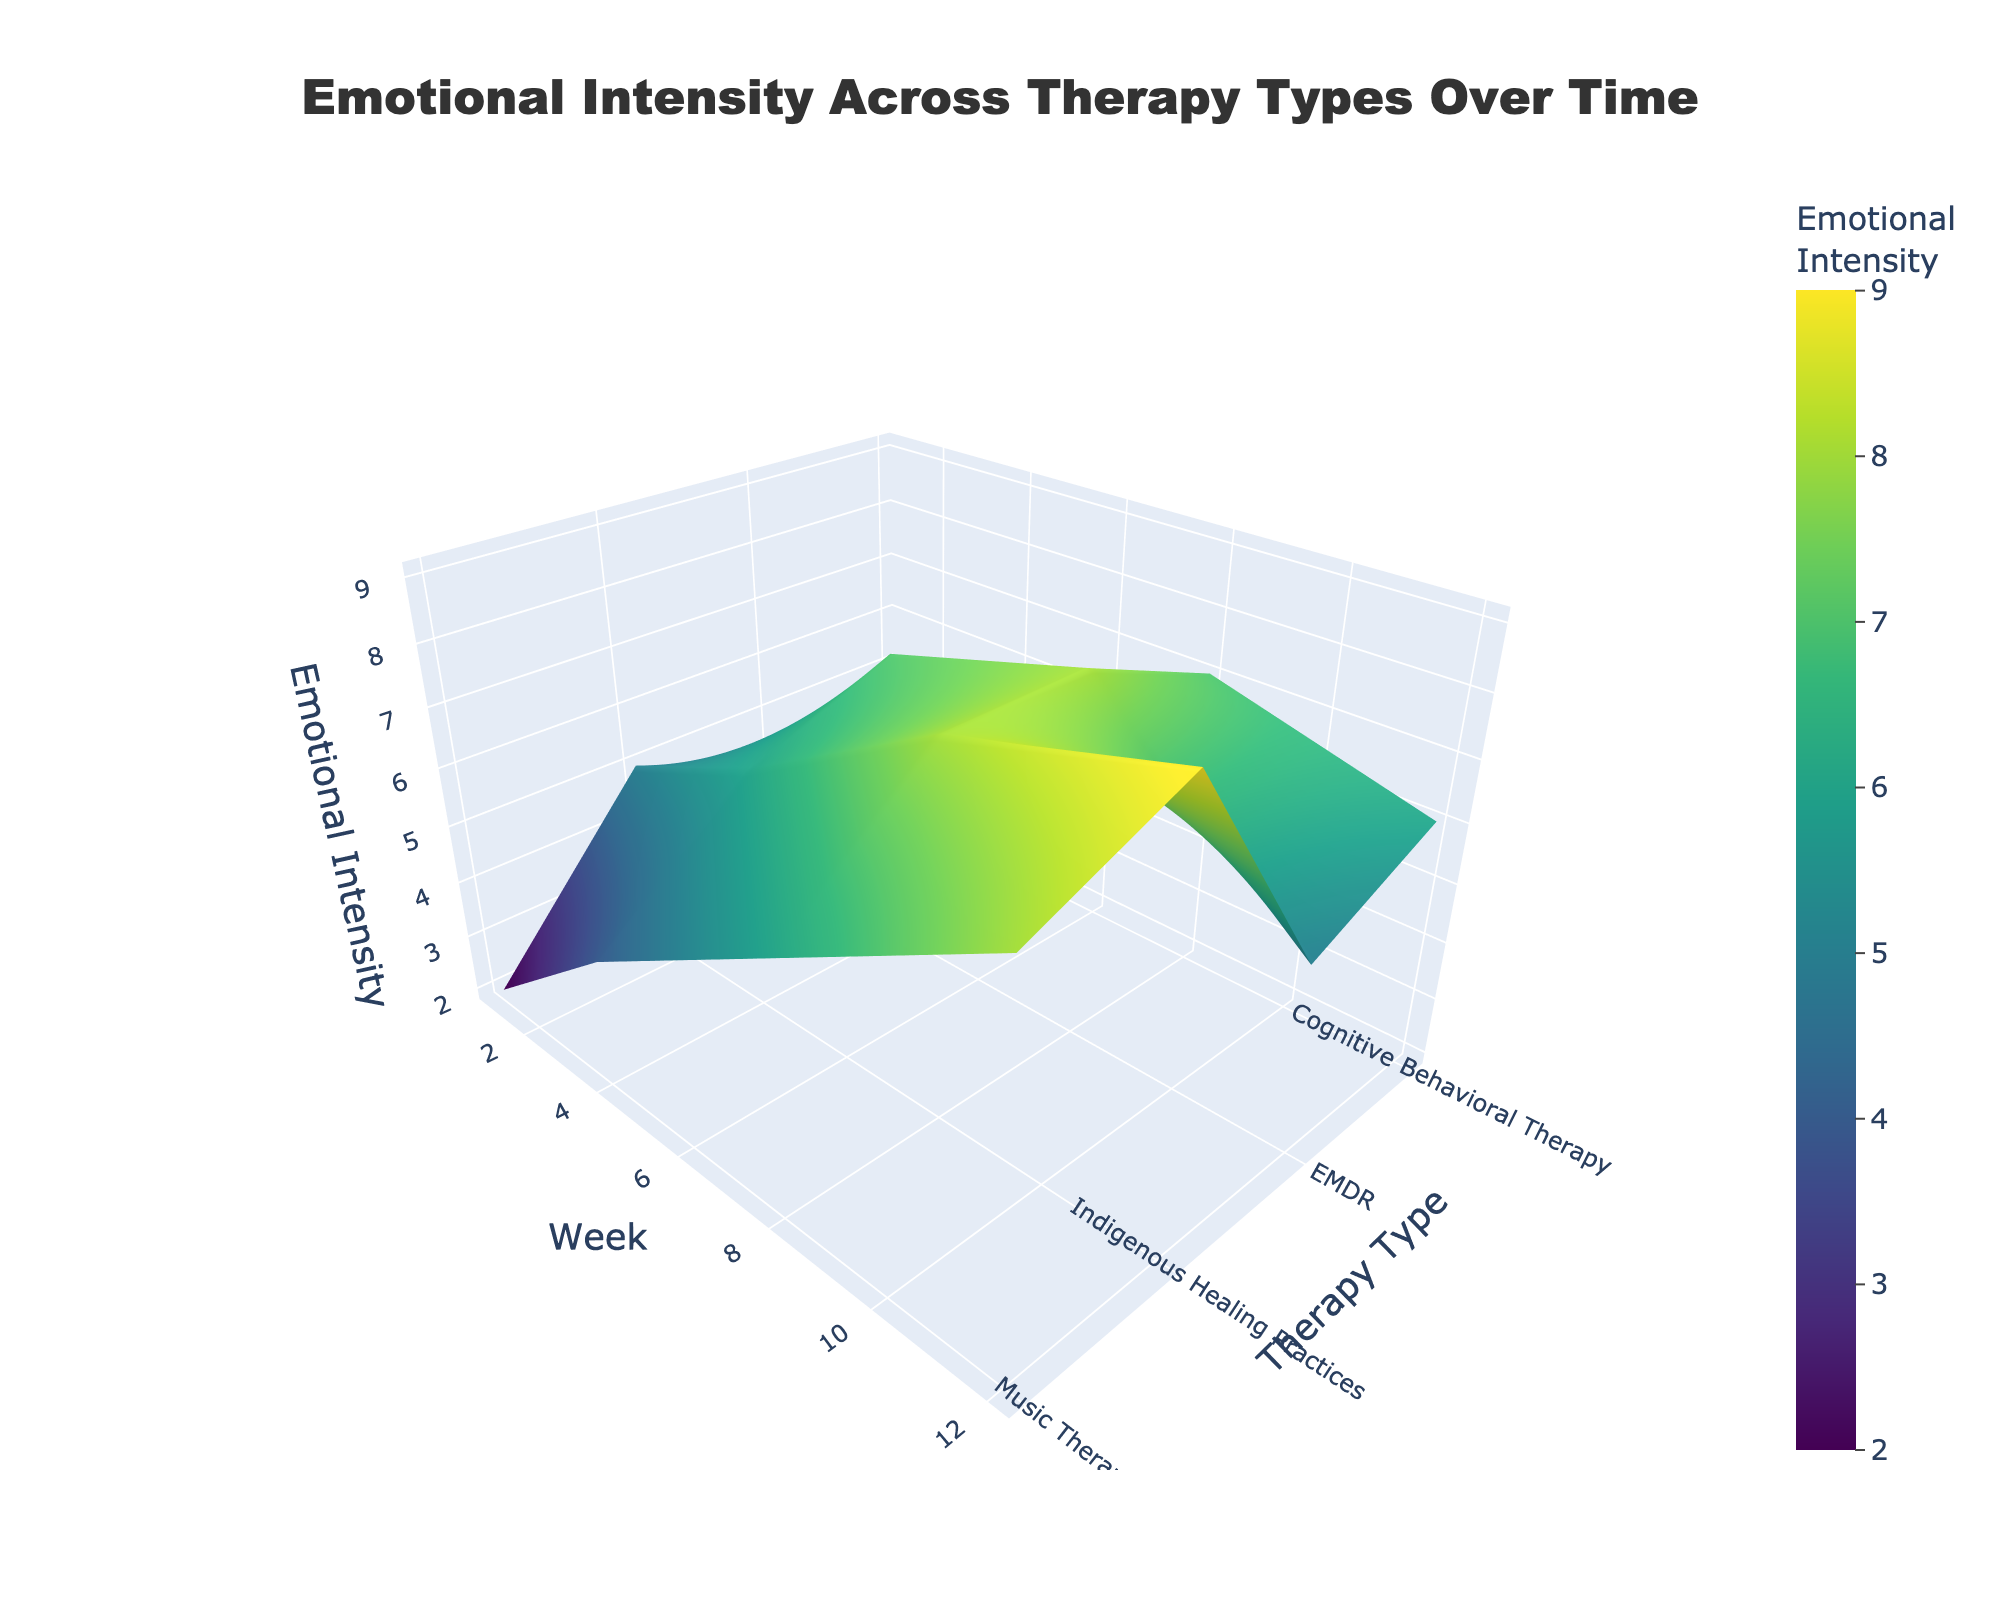What is the title of the figure? The title is usually at the top of the figure. In this case, it is specified to be 'Emotional Intensity Across Therapy Types Over Time'.
Answer: Emotional Intensity Across Therapy Types Over Time What are the axes labels? The x-axis, y-axis, and z-axis labels are provided within the 'scene' part of the code. They are 'Therapy Type', 'Week', and 'Emotional Intensity', respectively.
Answer: Therapy Type, Week, Emotional Intensity Which therapy type has the highest emotional intensity in Week 12? Looking at the Week 12 column, we find the highest value, 9, under Indigenous Healing Practices.
Answer: Indigenous Healing Practices What is the overall trend of emotional intensity for Cognitive Behavioral Therapy over time? By examining the values for Cognitive Behavioral Therapy, we can summarize the trend: 3, 5, 7, and 6. It increases from Week 1 to Week 8 and then slightly decreases by Week 12.
Answer: Increases then slightly decreases Comparing Music Therapy and EMDR, which has a higher emotional intensity in Week 8? By looking at Week 8 values for both therapies, we see Music Therapy has 6 while EMDR has 8.
Answer: EMDR What are the color indications in the figure? The color scale 'Viridis' indicates different levels of emotional intensity, with colors changing to denote varying intensity values.
Answer: Varying emotional intensity Which therapy type exhibits the most emotional intensity increase from Week 1 to Week 12? By checking the value differences between Week 1 and Week 12 for each therapy type, Indigenous Healing Practices shows the largest increase (9 - 5 = 4).
Answer: Indigenous Healing Practices What is the average emotional intensity for EMDR across all weeks? Sum the emotional intensities for EMDR (4, 7, 8, 5) and divide by the number of weeks (4). (4 + 7 + 8 + 5) / 4 = 6
Answer: 6 Across all therapy types, which week shows the highest median emotional intensity? List all emotional intensities for each week: Week 1 (3, 4, 2, 5), Week 4 (5, 7, 4, 6), Week 8 (7, 8, 6, 8), Week 12 (6, 5, 8, 9). The medians are 3.5 (Week 1), 5.5 (Week 4), 7.5 (Week 8), and 7 (Week 12). Week 8 has the highest median value of 7.5.
Answer: Week 8 